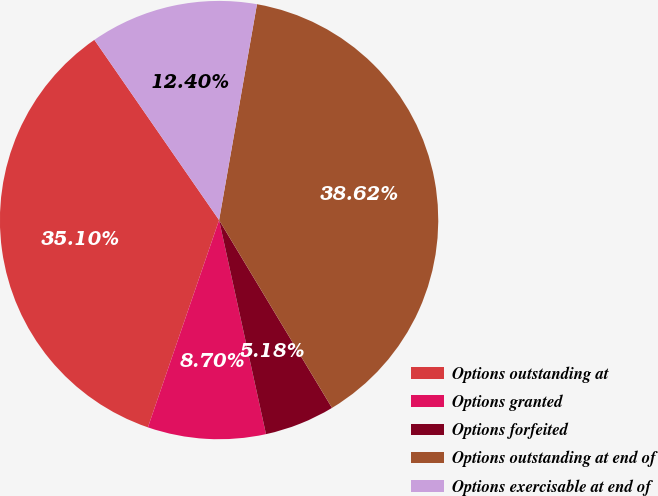Convert chart. <chart><loc_0><loc_0><loc_500><loc_500><pie_chart><fcel>Options outstanding at<fcel>Options granted<fcel>Options forfeited<fcel>Options outstanding at end of<fcel>Options exercisable at end of<nl><fcel>35.1%<fcel>8.7%<fcel>5.18%<fcel>38.62%<fcel>12.4%<nl></chart> 